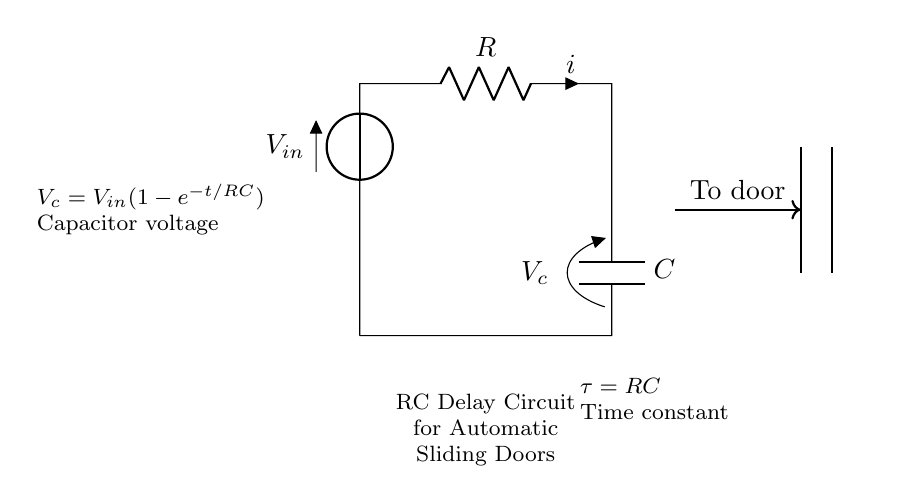What components are used in this circuit? The circuit consists of a resistor and a capacitor, as indicated in the diagram. The resistor is labeled R, and the capacitor is labeled C.
Answer: Resistor and Capacitor What is the input voltage in the circuit? The input voltage, denoted by V-in, is indicated at the top of the circuit. There is no specific value provided, so it remains a general label.
Answer: V-in What does the time constant represent? The time constant, represented by the symbol tau (τ), is calculated as the product of the resistance (R) and the capacitance (C). It indicates how quickly the voltage across the capacitor will charge or discharge.
Answer: RC What is the voltage across the capacitor during charging? The voltage across the capacitor during charging is given by the formula V-c = V-in(1-e^(-t/RC)). This shows that the voltage depends on time (t) and the values of R and C.
Answer: V-in(1-e^(-t/RC)) How does the capacitor voltage change over time? The capacitor voltage increases over time based on the charging formula, approaching the input voltage value asymptotically, meaning it gets closer but never exceeds V-in as time increases.
Answer: Increases towards V-in What happens when the capacitor is fully charged? When the capacitor is fully charged, its voltage equals the input voltage (V-in), and the current in the circuit drops to zero, indicating no further charging occurs.
Answer: Current is zero What role does the RC delay circuit play for sliding doors? The RC delay circuit provides a time delay before the doors open, ensuring they don't activate instantly. This enhances safety and user experience by allowing for a brief pause.
Answer: Time delay for safe operation 